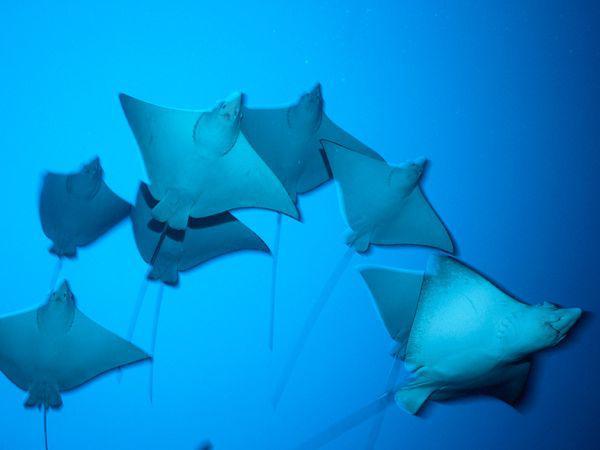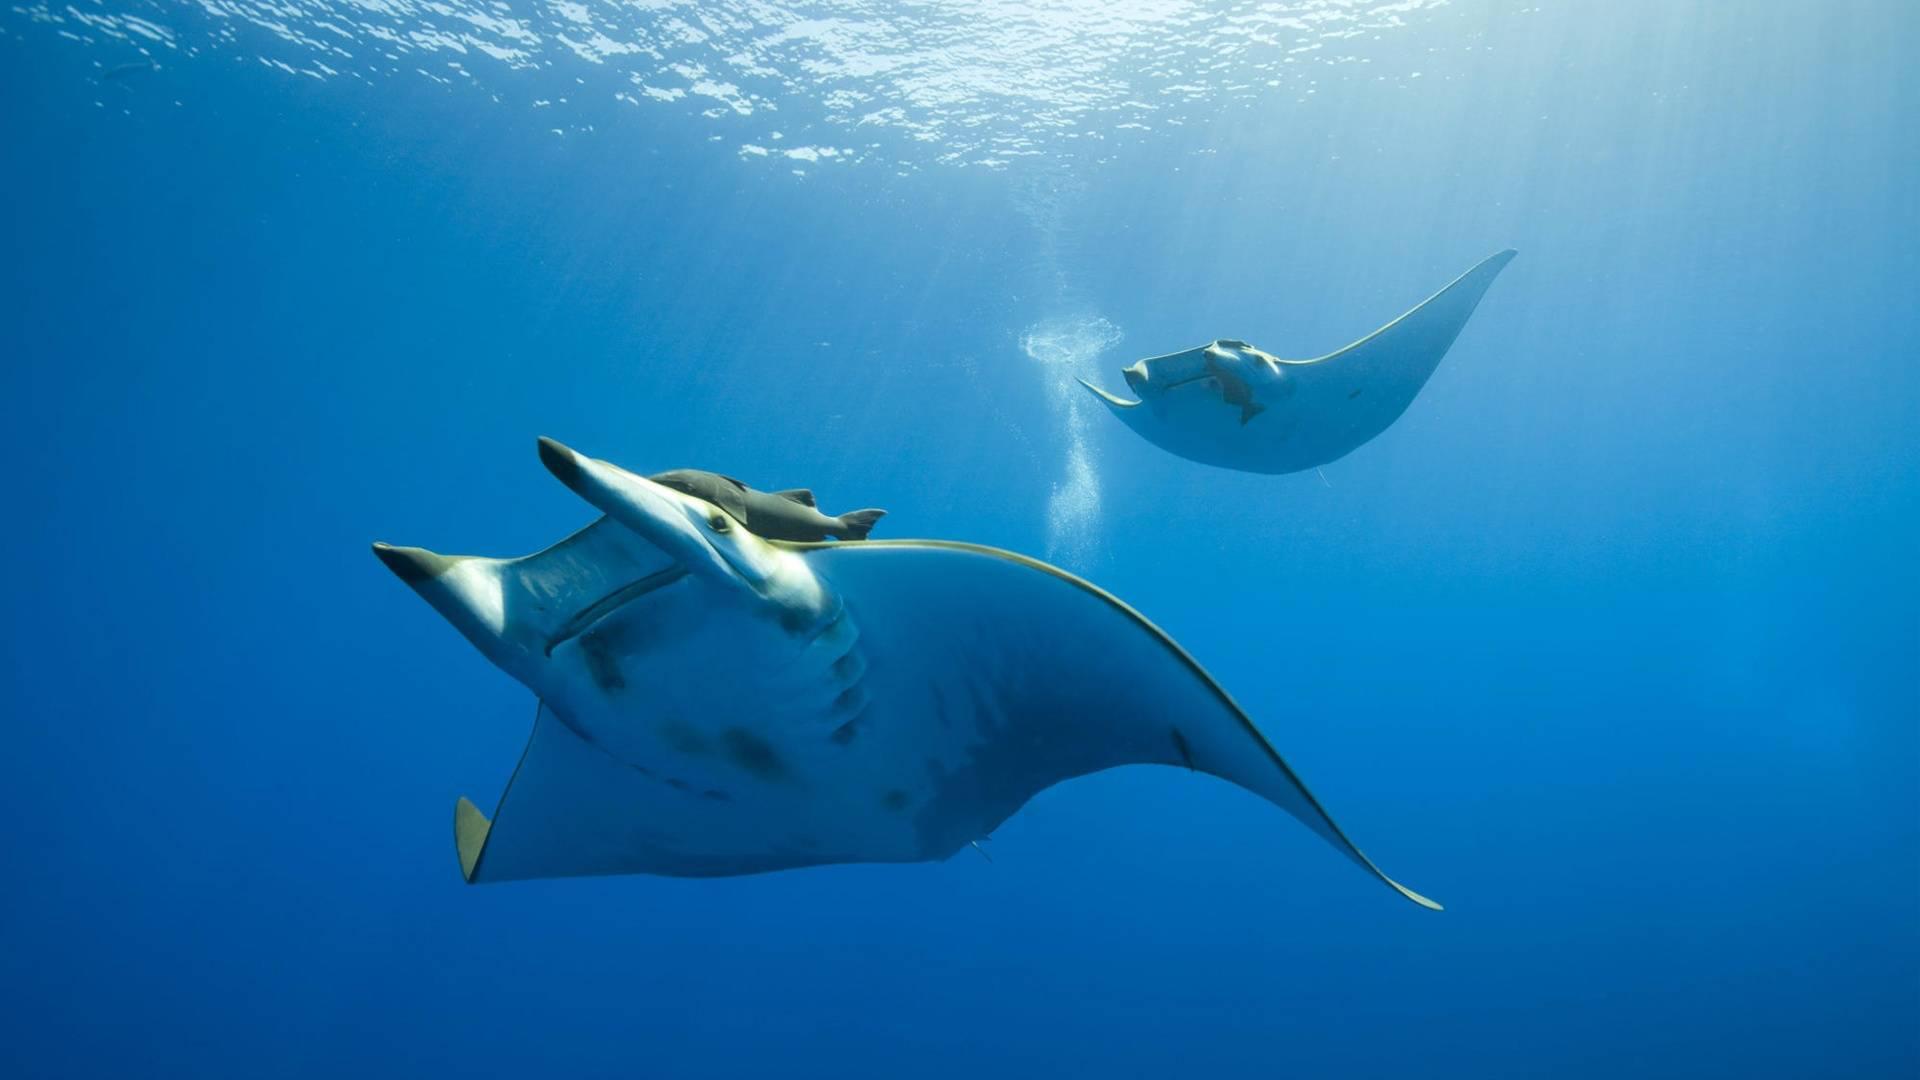The first image is the image on the left, the second image is the image on the right. For the images shown, is this caption "There are two manta rays in total." true? Answer yes or no. No. The first image is the image on the left, the second image is the image on the right. Analyze the images presented: Is the assertion "An image contains exactly two stingray swimming in blue water with light shining in the scene." valid? Answer yes or no. Yes. 